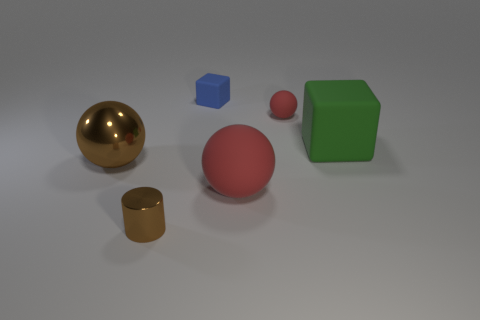Add 1 tiny metal things. How many objects exist? 7 Subtract all blocks. How many objects are left? 4 Subtract 0 cyan blocks. How many objects are left? 6 Subtract all red matte things. Subtract all blue blocks. How many objects are left? 3 Add 5 tiny blue cubes. How many tiny blue cubes are left? 6 Add 1 tiny brown objects. How many tiny brown objects exist? 2 